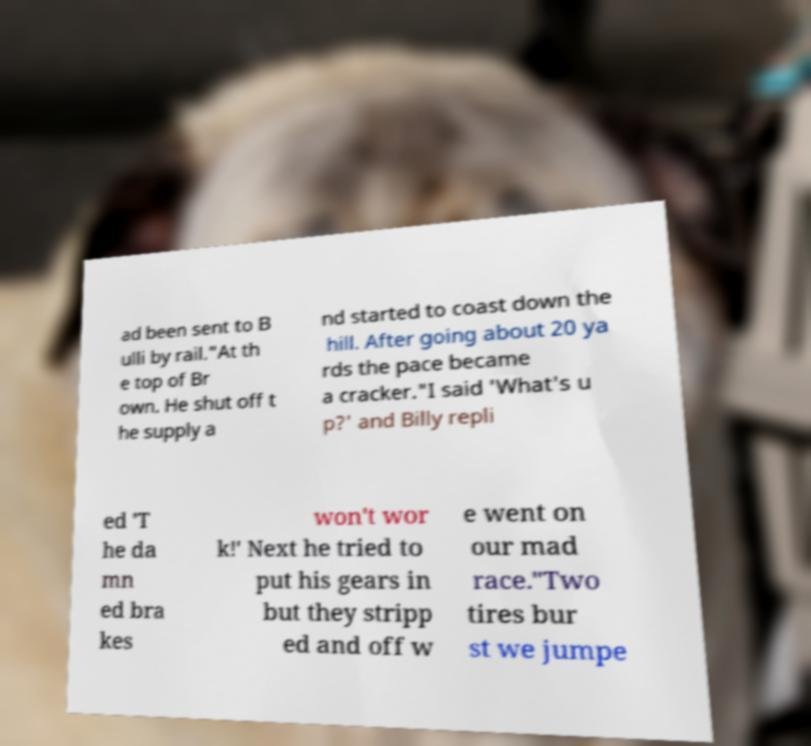Please identify and transcribe the text found in this image. ad been sent to B ulli by rail."At th e top of Br own. He shut off t he supply a nd started to coast down the hill. After going about 20 ya rds the pace became a cracker."I said 'What's u p?' and Billy repli ed 'T he da mn ed bra kes won't wor k!' Next he tried to put his gears in but they stripp ed and off w e went on our mad race."Two tires bur st we jumpe 